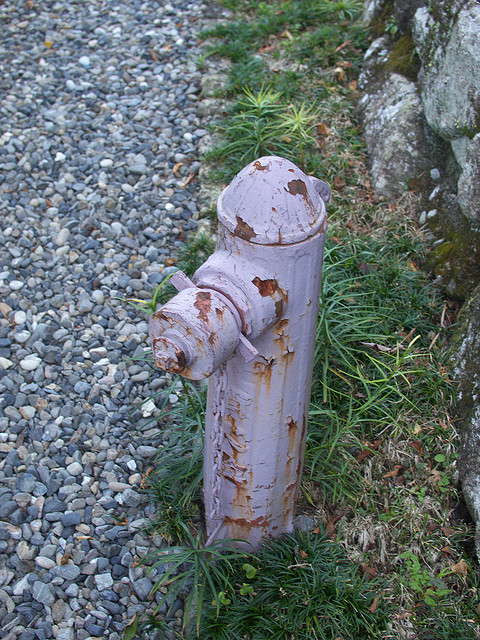Describe a short realistic scenario involving the fireplug. In a short realistic scenario, a local maintenance worker might come by to inspect the fireplug. Noting its weathered condition, they document the need for a fresh coat of paint and minor repairs. They make arrangements to return later with the necessary tools and materials to refurbish the fireplug, ensuring it remains in good working condition for future emergencies. 